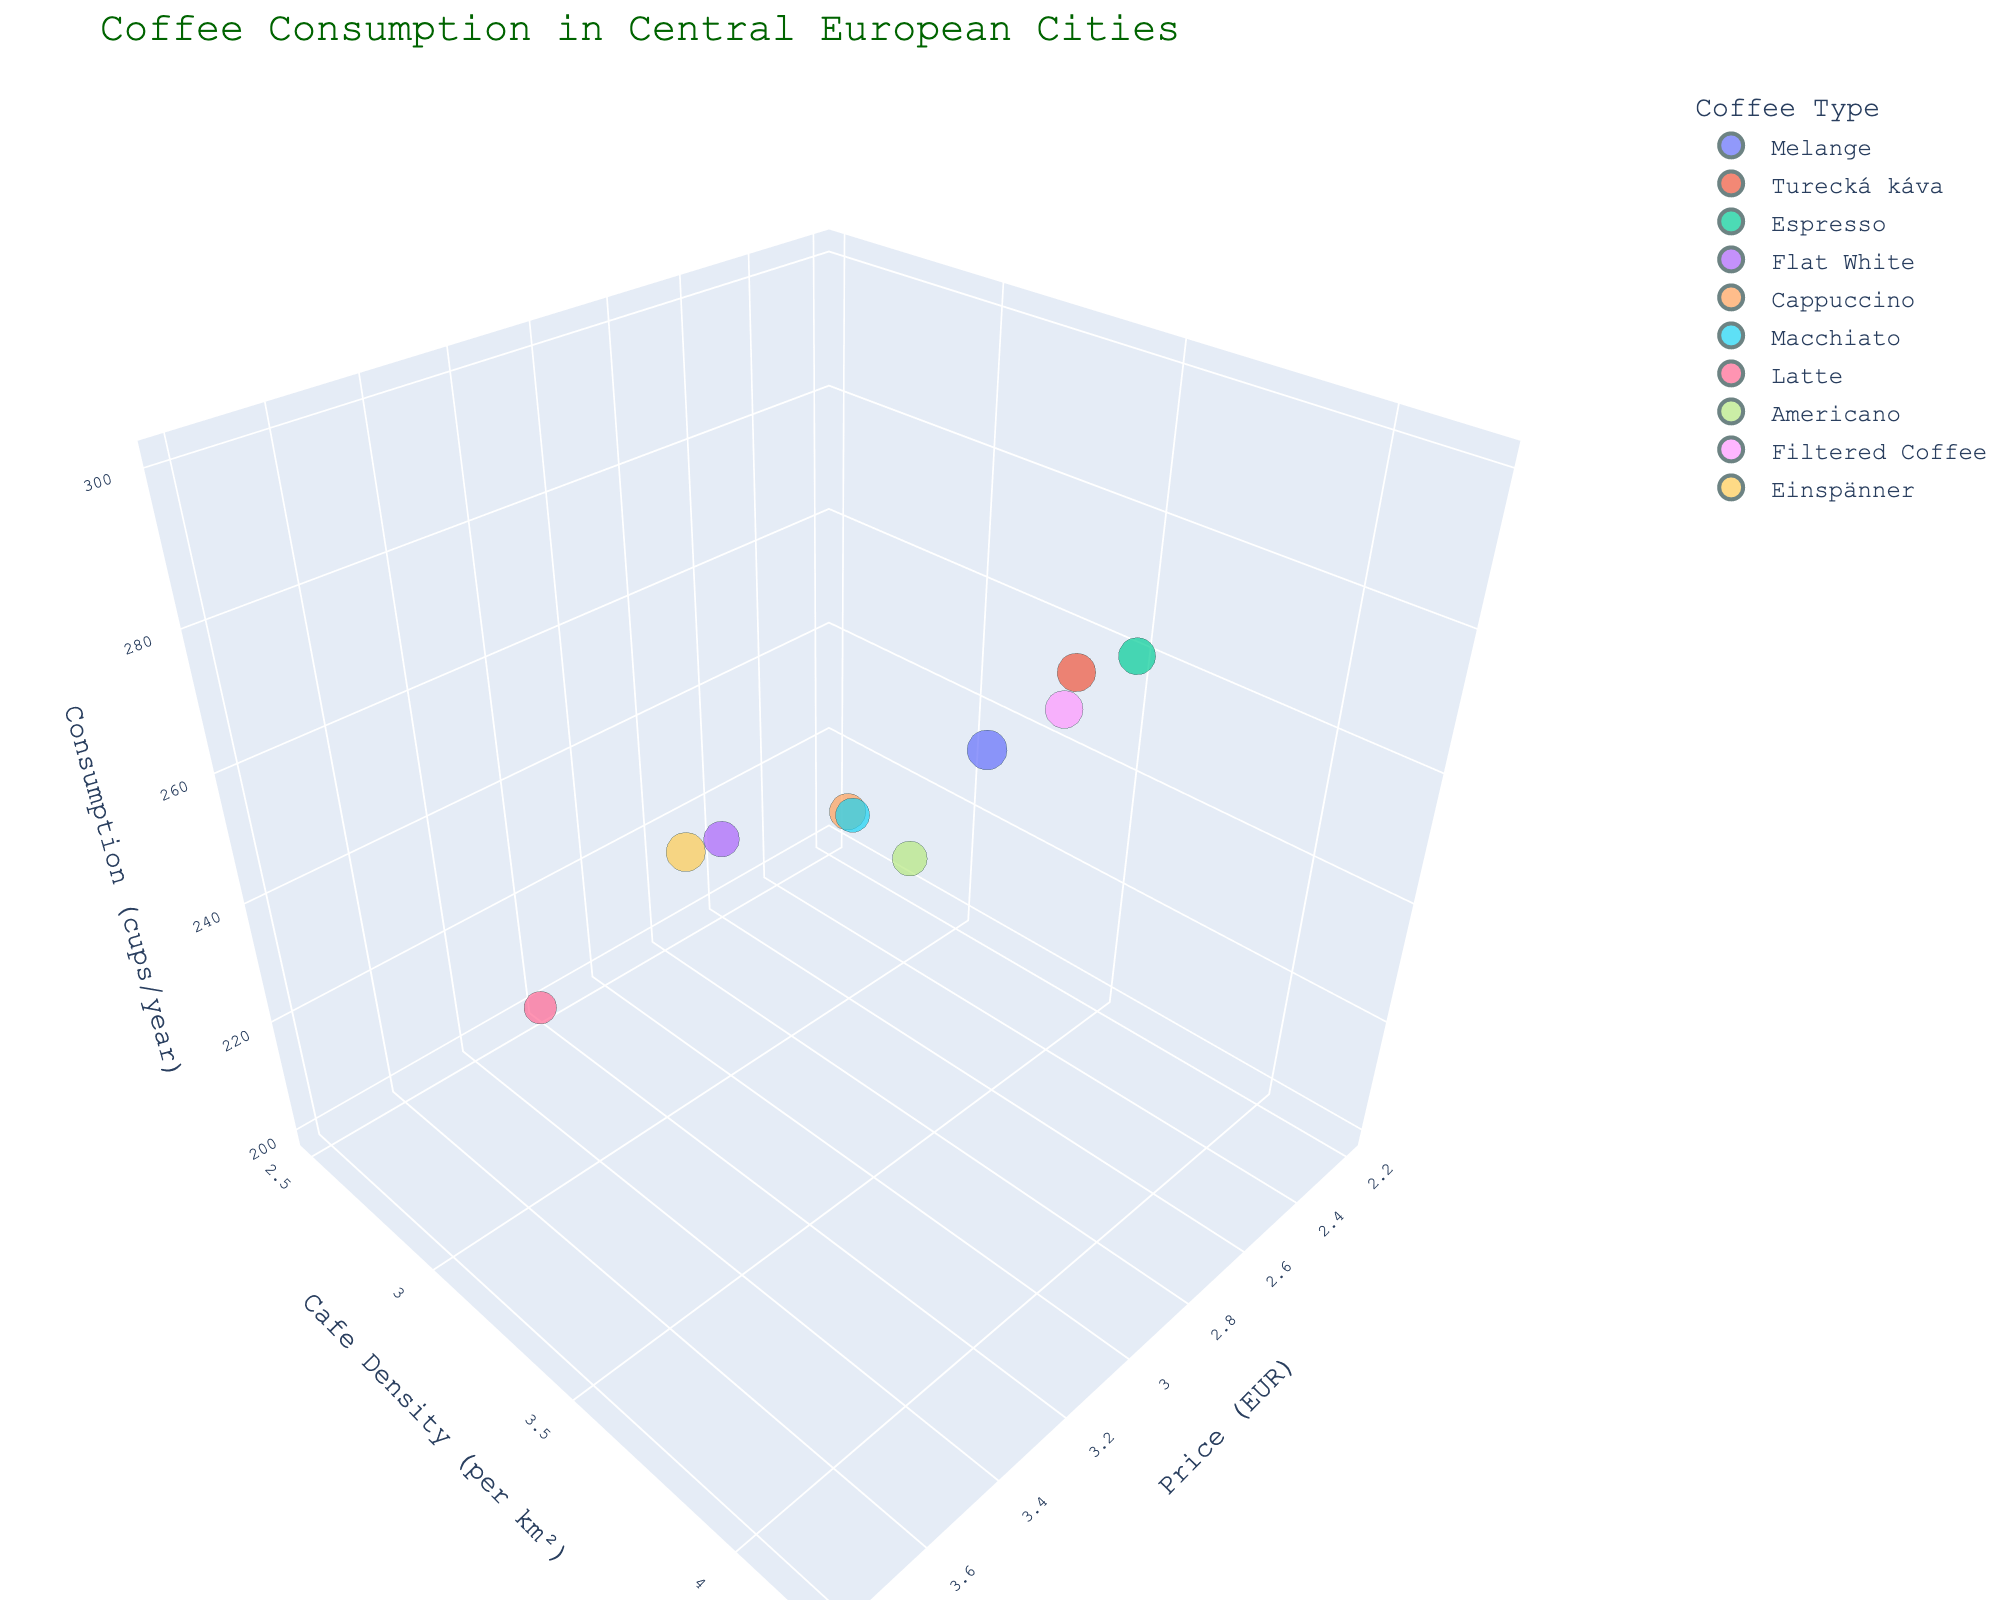What is the title of the 3D bubble chart? The title is typically found at the top of the chart. It gives an overview of the information being presented.
Answer: Coffee Consumption in Central European Cities Which city has the highest average price for coffee? By looking at the chart where the x-axis represents the average price, the city associated with the highest bubble along this axis corresponds to the highest average price.
Answer: Salzburg Which coffee type is associated with the lowest cafe density per km²? The y-axis represents cafe density; identify which coffee type's bubble is lowest along this axis.
Answer: Latte What is the general trend between consumption and average price for coffee? Observe the overall pattern: whether higher consumption bubbles are associated with higher or lower prices, and note any exceptions.
Answer: No clear trend How does the cappuccino in Bratislava compare to the espresso in Budapest in terms of cafe density? Identify the bubbles labeled "Bratislava" and "Budapest" and compare their positions along the y-axis.
Answer: Bratislava has a higher cafe density Which city has the largest bubble size, and what does it represent? The size of the bubble represents consumption; the largest bubble will correspond to the highest consumption value.
Answer: Vienna, representing 300 cups per capita per year What is the average price difference between the most and least expensive coffees? Identify the highest and lowest values along the x-axis, then subtract the lowest from the highest.
Answer: 1.60 EUR Which city has a lower cafe density but higher coffee consumption compared to Zagreb? Find Zagreb's bubble and look for another bubble that is lower on the y-axis but higher on the z-axis.
Answer: Salzburg What is the relationship between price and cafe density for flat white in Krakow? Find the bubble for Krakow and observe its coordinates on the x (price) and y (cafe density) axes to describe the relationship.
Answer: Medium price, medium density How does coffee consumption in Prague compare to that in Vienna? Compare the z-axis positions of bubbles labeled Prague and Vienna for their consumption values.
Answer: Vienna has higher consumption 